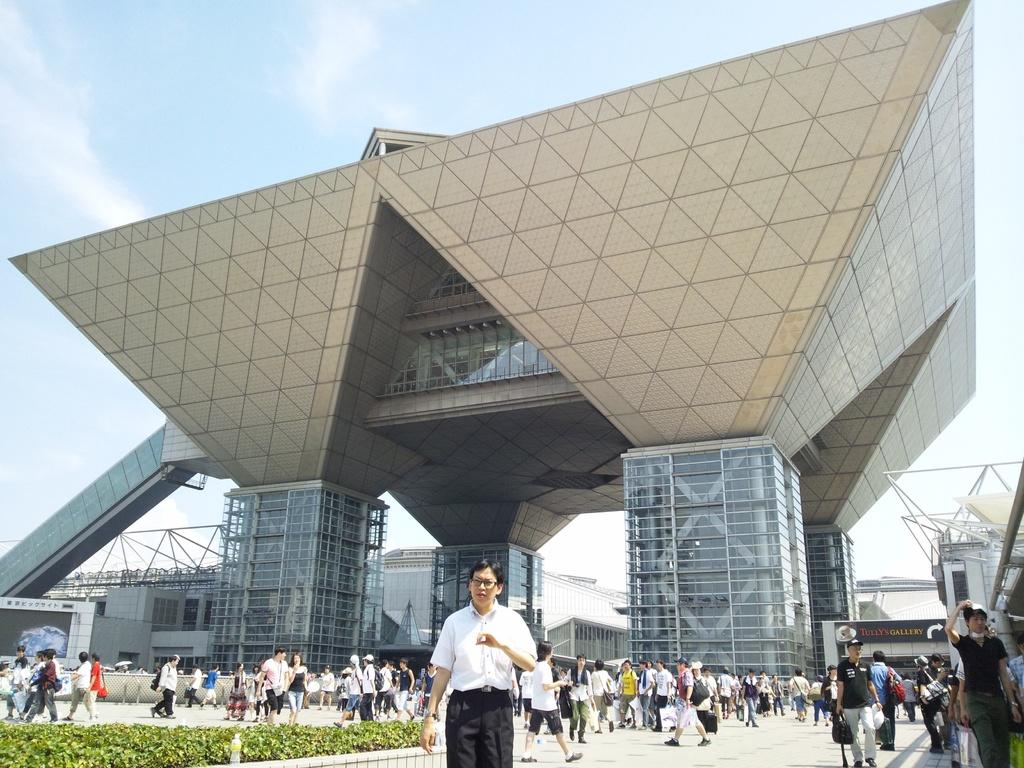What is located at the bottom of the image? There are people, walkways, and plants at the bottom of the image. What can be seen in the background of the image? There are buildings, glass objects, rods, a name board, and the sky visible in the background. What type of garden is present in the image? There is no garden present in the image. What type of suit is the person wearing in the image? There is no person wearing a suit in the image. 